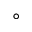<formula> <loc_0><loc_0><loc_500><loc_500>^ { \circ }</formula> 